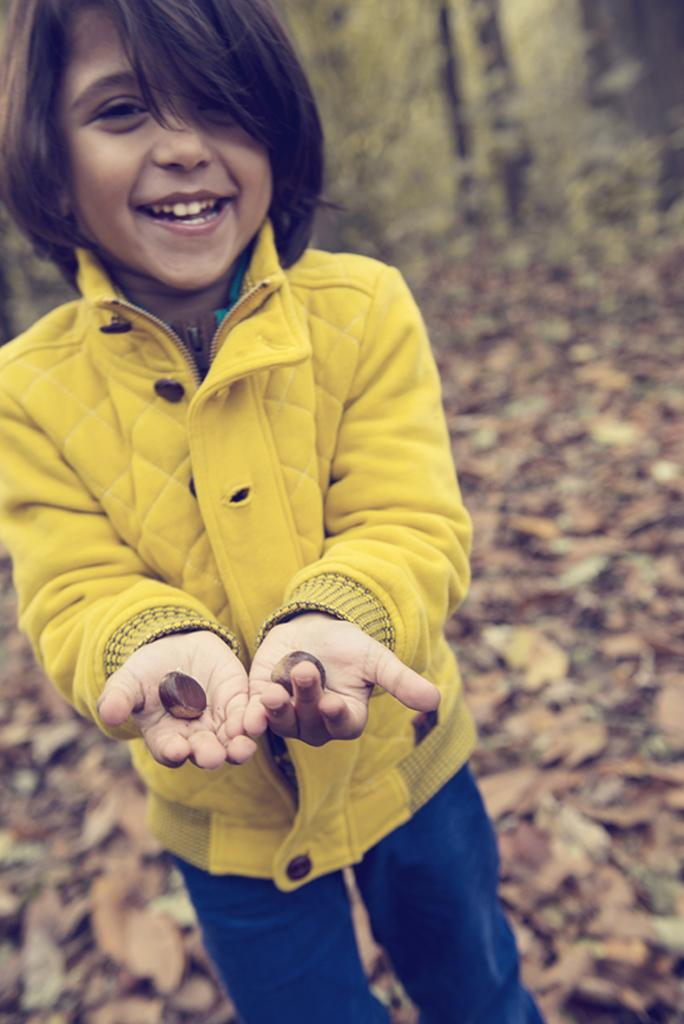Who is the main subject in the image? There is a girl in the image. What is the girl holding in her hand? The girl is holding two stones in her hand. What can be seen on the ground in the image? There are leaves on the ground in the image. How would you describe the background of the image? The background of the image is blurred. What type of lettuce can be seen in the girl's apparel in the image? There is no lettuce or any type of apparel mentioned in the image. The girl is simply holding two stones in her hand, and there is no mention of her wearing anything. 